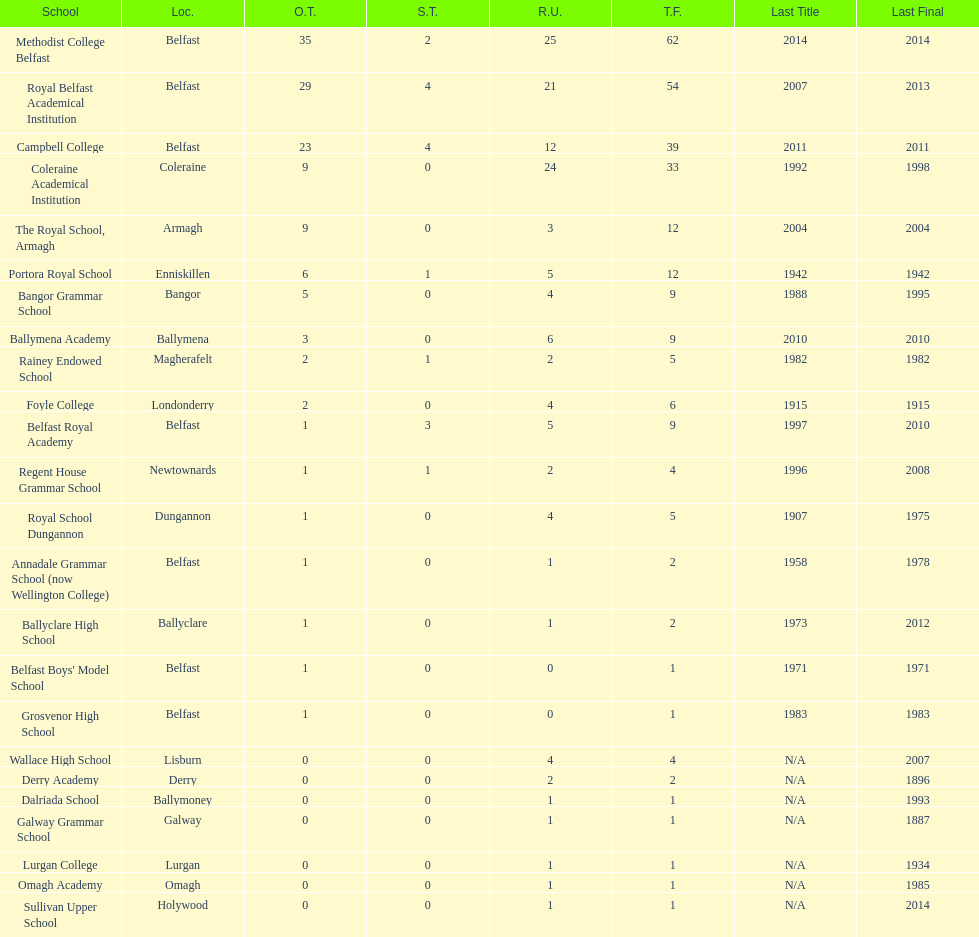What number of total finals does foyle college have? 6. 